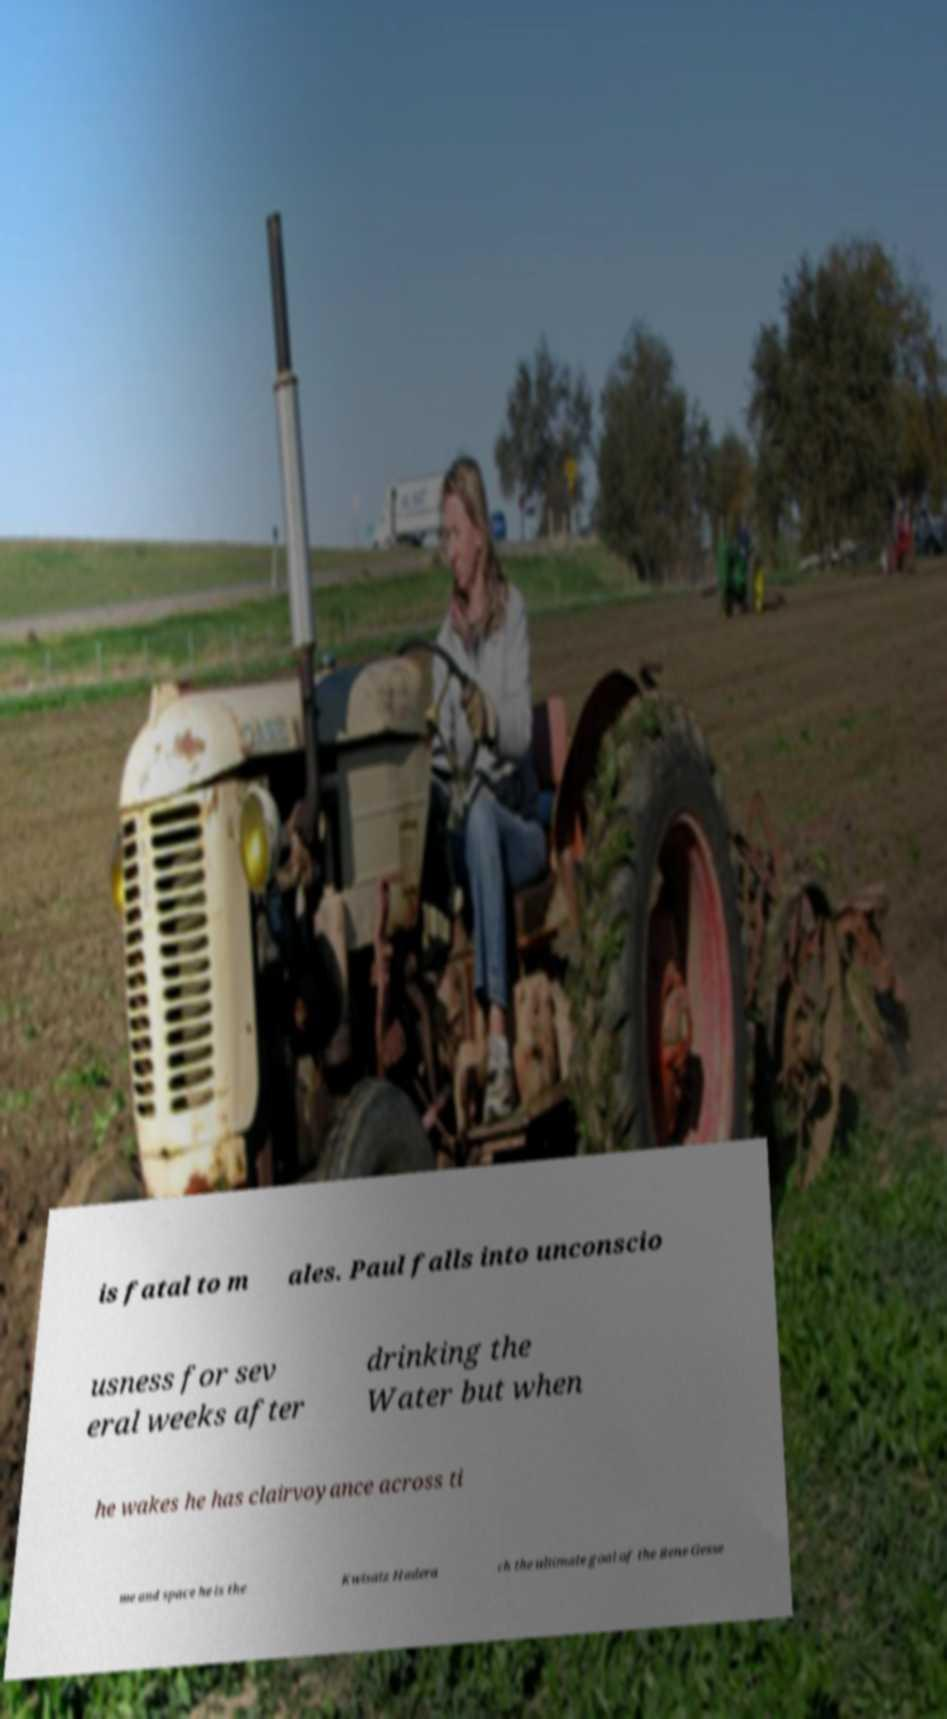Please read and relay the text visible in this image. What does it say? is fatal to m ales. Paul falls into unconscio usness for sev eral weeks after drinking the Water but when he wakes he has clairvoyance across ti me and space he is the Kwisatz Hadera ch the ultimate goal of the Bene Gesse 